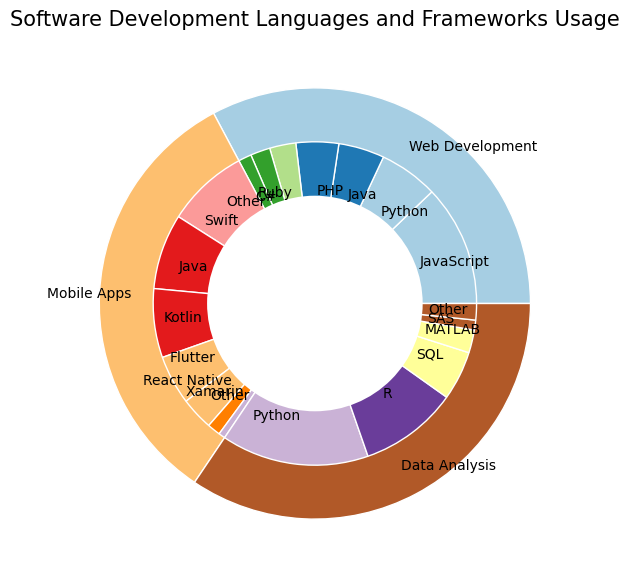What is the most popular language for web development? The outer pie chart represents different project types. The inner pie chart shows the languages used within each project type. For web development, the largest segment in the inner ring corresponds to JavaScript.
Answer: JavaScript Which mobile apps development language is more popular, Kotlin or React Native? In the category of mobile apps development, compare the size of the segments for Kotlin and React Native in the inner pie chart. Kotlin has a larger segment than React Native, indicating higher popularity.
Answer: Kotlin What makes up the majority of data analysis languages? The segments in the inner pie chart corresponding to data analysis reveal that Python and R occupy the largest portions. Summing their percentages shows Python at 45% and R at 30%. Together, they make up 75% of the data analysis languages.
Answer: Python and R Which project type has the least variety of languages/frameworks used? Count the individual segments in the inner ring for each project type. Mobile apps show the least variety with only 7 different languages/frameworks used, compared to web development and data analysis.
Answer: Mobile Apps If you sum up the popularity of Python across all project types, what is the total? Python appears in web development with an 18% share and in data analysis with a 45% share. Adding these percentages gives 18 + 45 = 63%.
Answer: 63% In web development, which has more popularity: Java or PHP? Look at the web development segments for Java and PHP in the inner pie chart. Java has a 14% share, and PHP has a 13% share. Java has a slight edge over PHP.
Answer: Java What is the least used language in data analysis? In the data analysis category, identify the smallest segment in the inner pie chart. SAS has the smallest segment with a 3% share.
Answer: SAS Compare the overall popularity of web development languages to data analysis languages. Which one is more popular? Sum the outer ring segments for web development and data analysis. Web development has a total of 37 + 18 + 14 + 13 + 8 + 6 + 4 = 100%. Data analysis totals 45 + 30 + 15 + 7 + 3 + 5 = 105%. Data analysis has a higher overall popularity.
Answer: Data Analysis If another language is added to mobile apps with a popularity of 5%, what would be the new total percentage for mobile apps? Mobile apps currently have a total popularity sum of 25 + 23 + 21 + 15 + 10 + 4 + 2 = 100%. Adding another language with a 5% share would increase this total to 100 + 5 = 105%.
Answer: 105% What color represents the R language in the data analysis section? Locate the R segment in the inner pie chart for the data analysis section and observe its color, which is a shade of blue in the color palette used.
Answer: Blue 